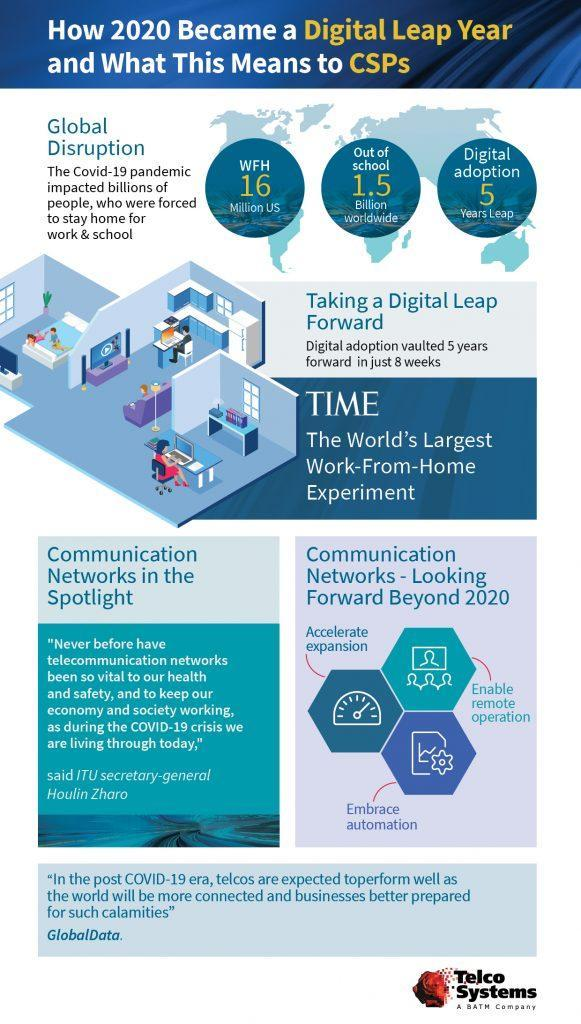What are the expected enhanced features of Communication technologies?
Answer the question with a short phrase. Accelerate expansion, Enable remote operation, embrace automation How many children (in billion) are learning from home due to Corona outbreak? 1.5 